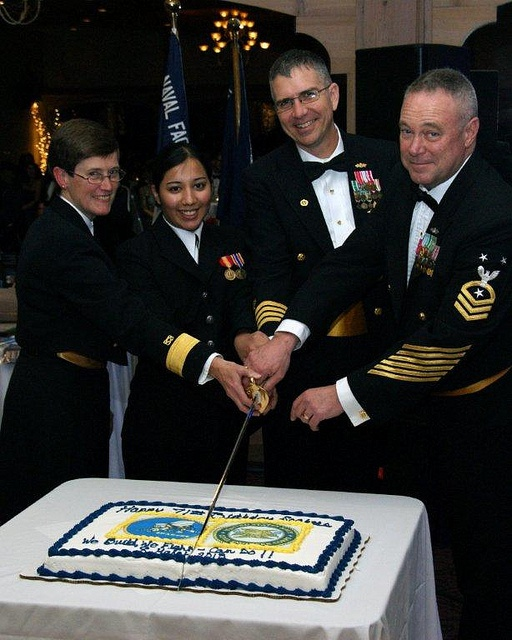Describe the objects in this image and their specific colors. I can see people in black, brown, gray, and maroon tones, dining table in black, lightgray, darkgray, and gray tones, people in black, brown, maroon, and gray tones, people in black, brown, and maroon tones, and people in black, lightgray, brown, and gray tones in this image. 